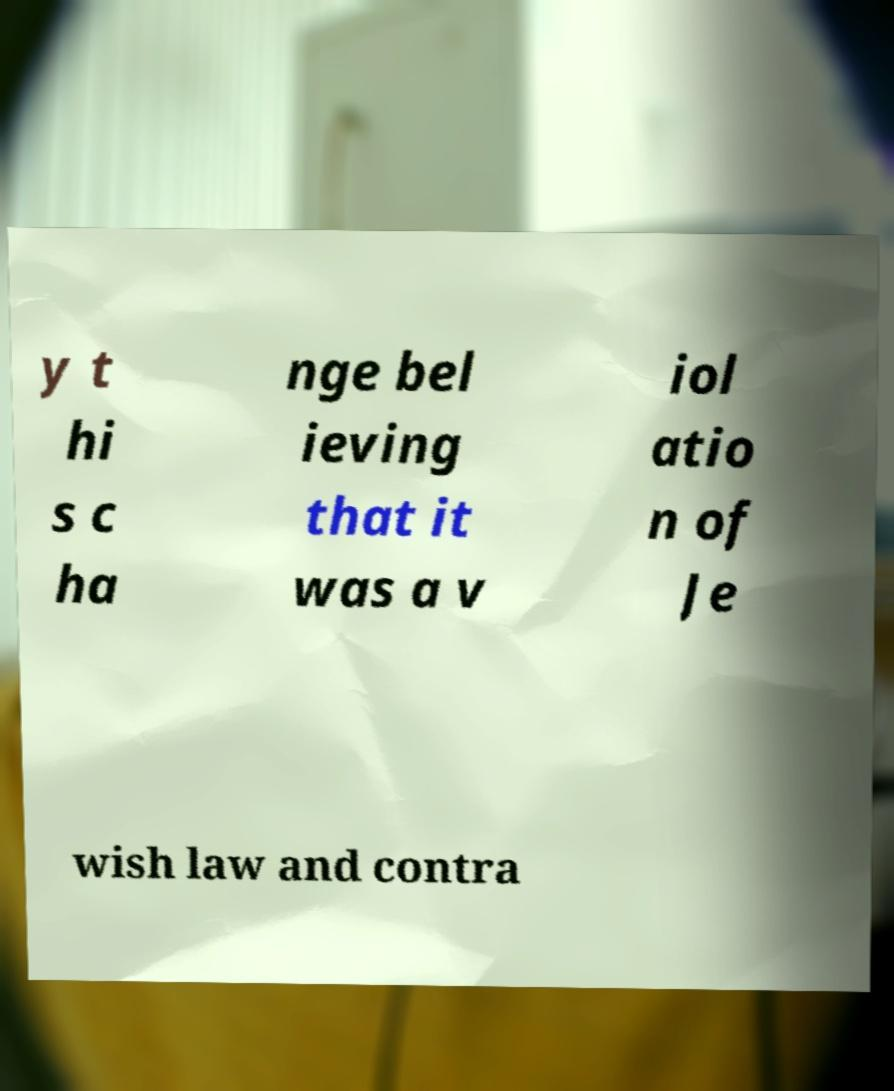Could you assist in decoding the text presented in this image and type it out clearly? y t hi s c ha nge bel ieving that it was a v iol atio n of Je wish law and contra 